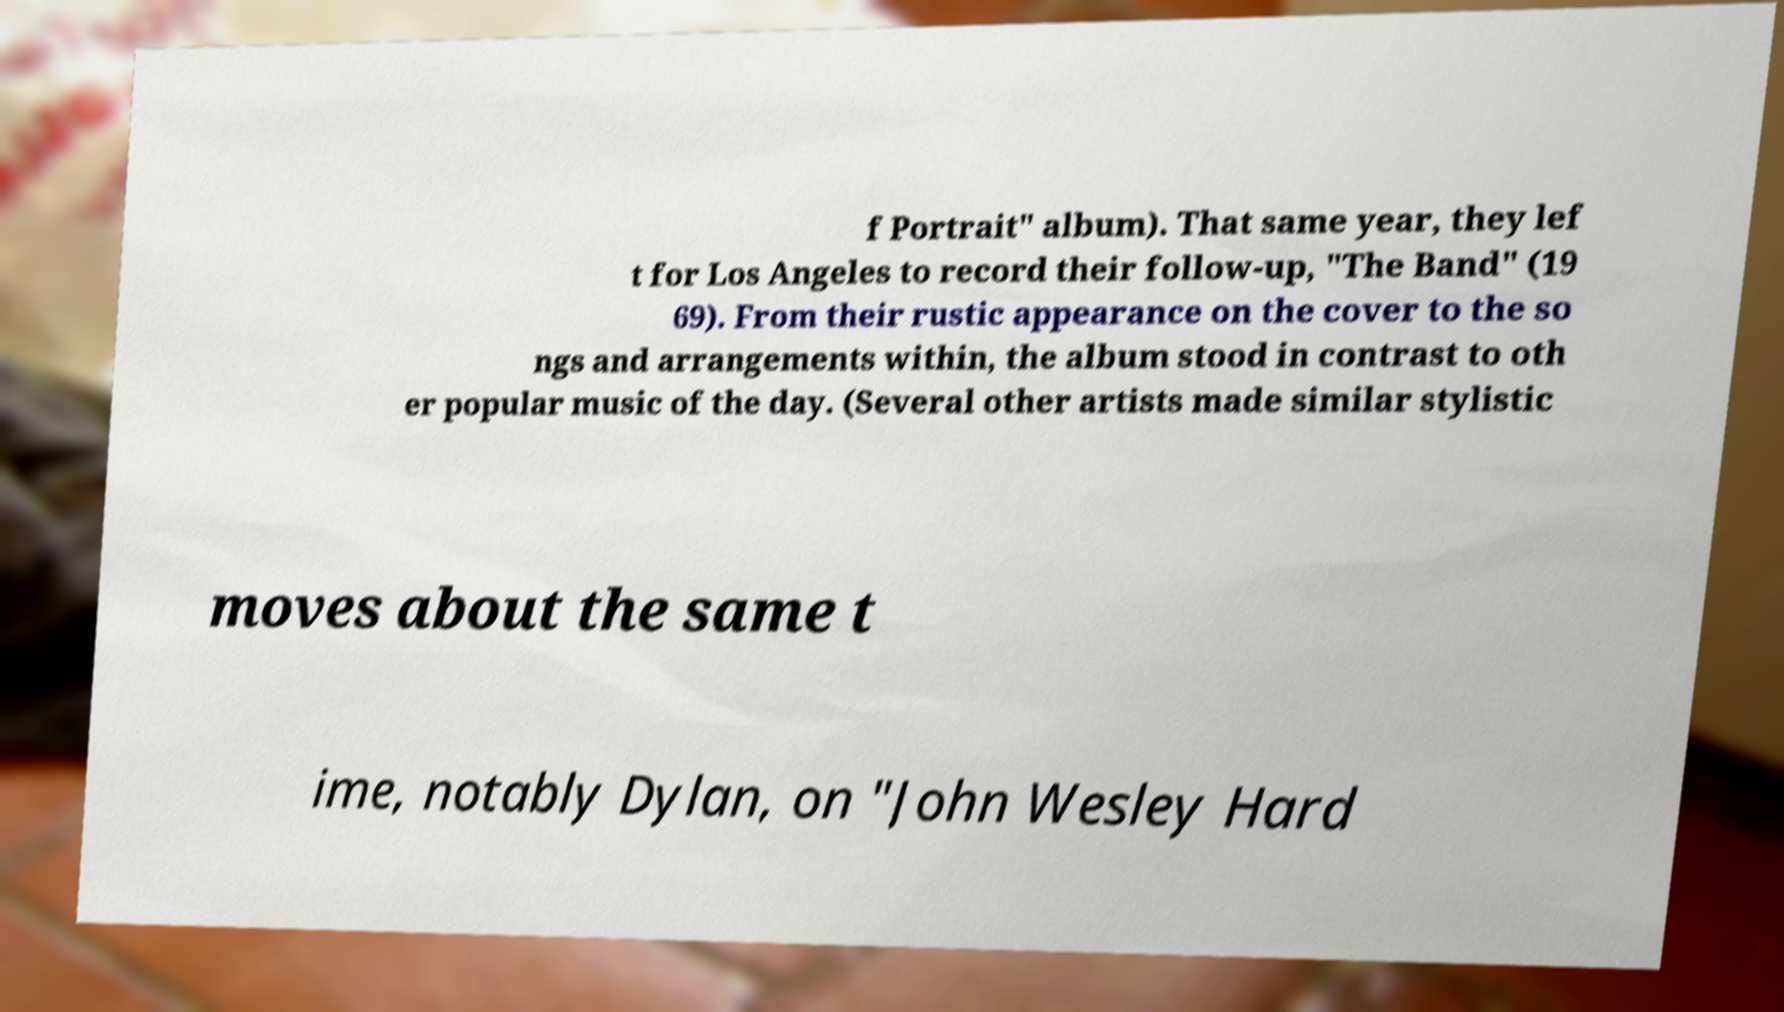There's text embedded in this image that I need extracted. Can you transcribe it verbatim? f Portrait" album). That same year, they lef t for Los Angeles to record their follow-up, "The Band" (19 69). From their rustic appearance on the cover to the so ngs and arrangements within, the album stood in contrast to oth er popular music of the day. (Several other artists made similar stylistic moves about the same t ime, notably Dylan, on "John Wesley Hard 